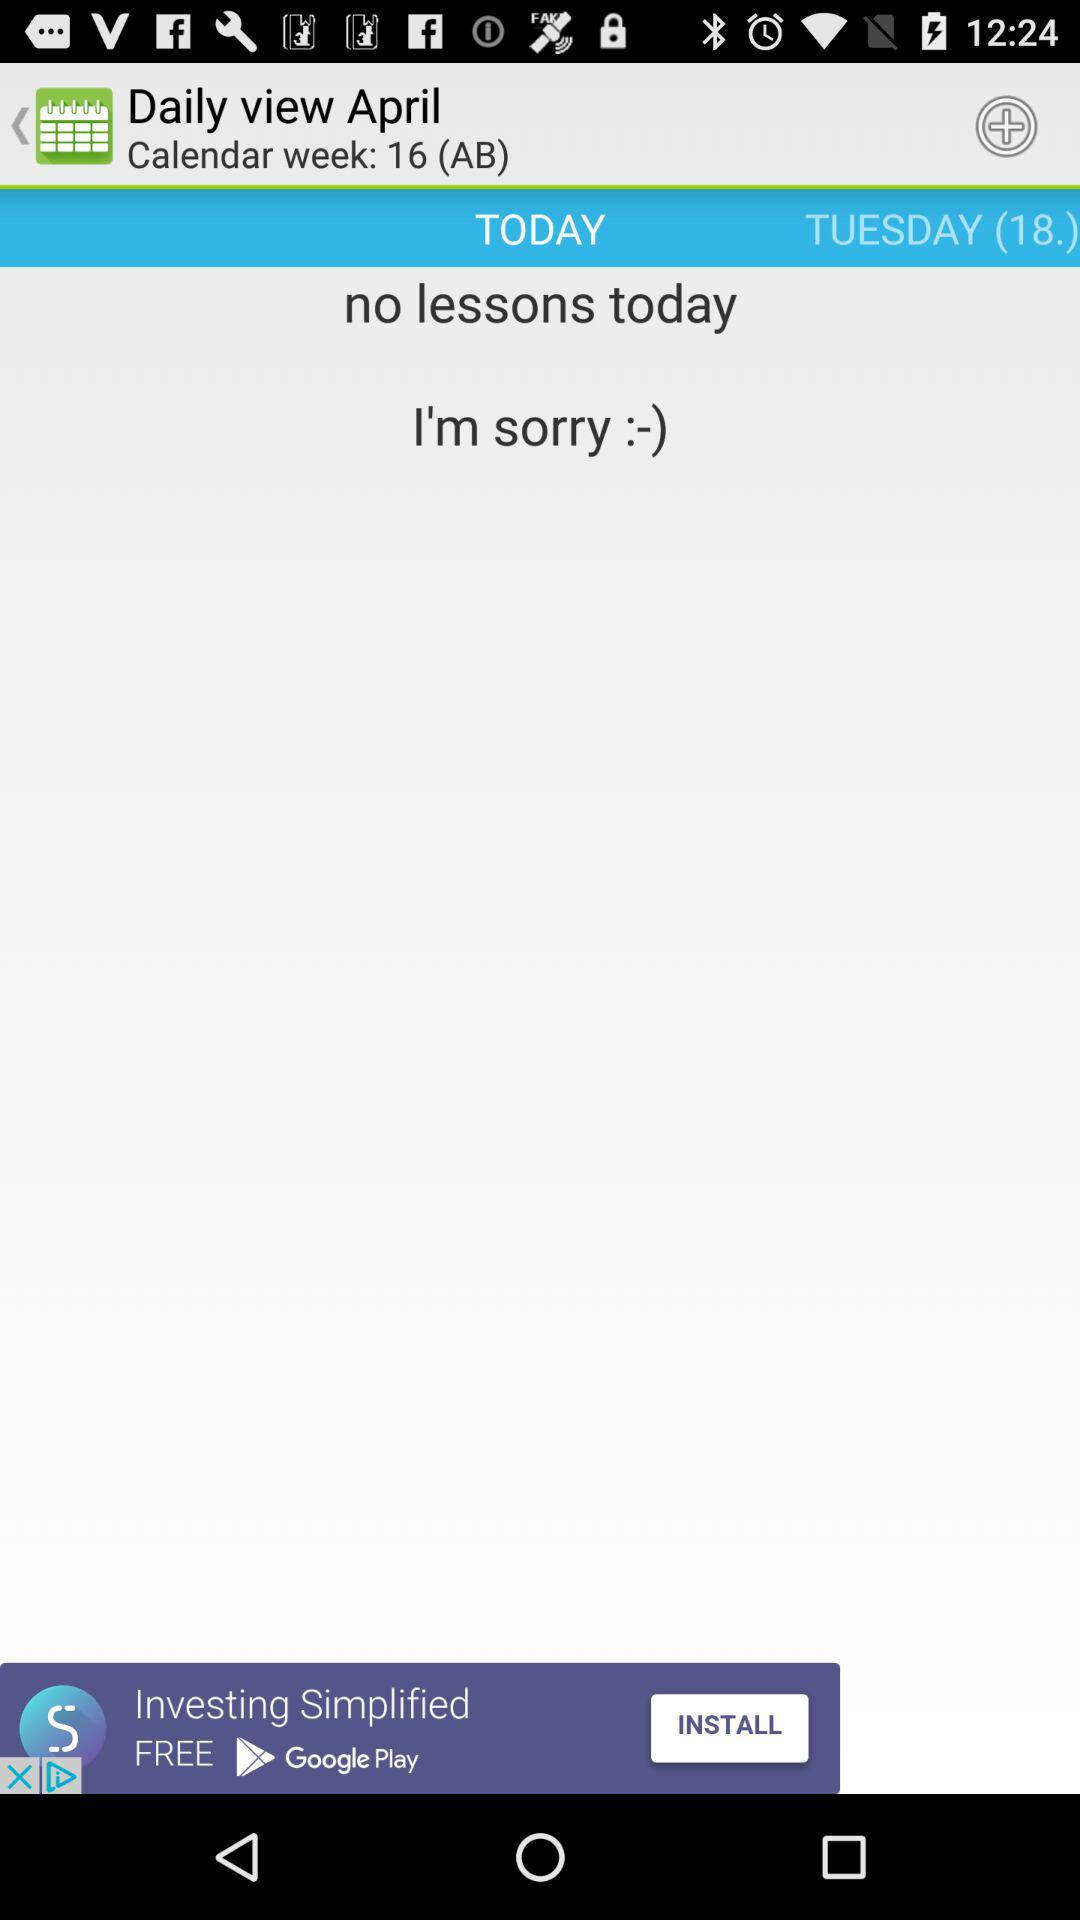What is the day today?
When the provided information is insufficient, respond with <no answer>. <no answer> 